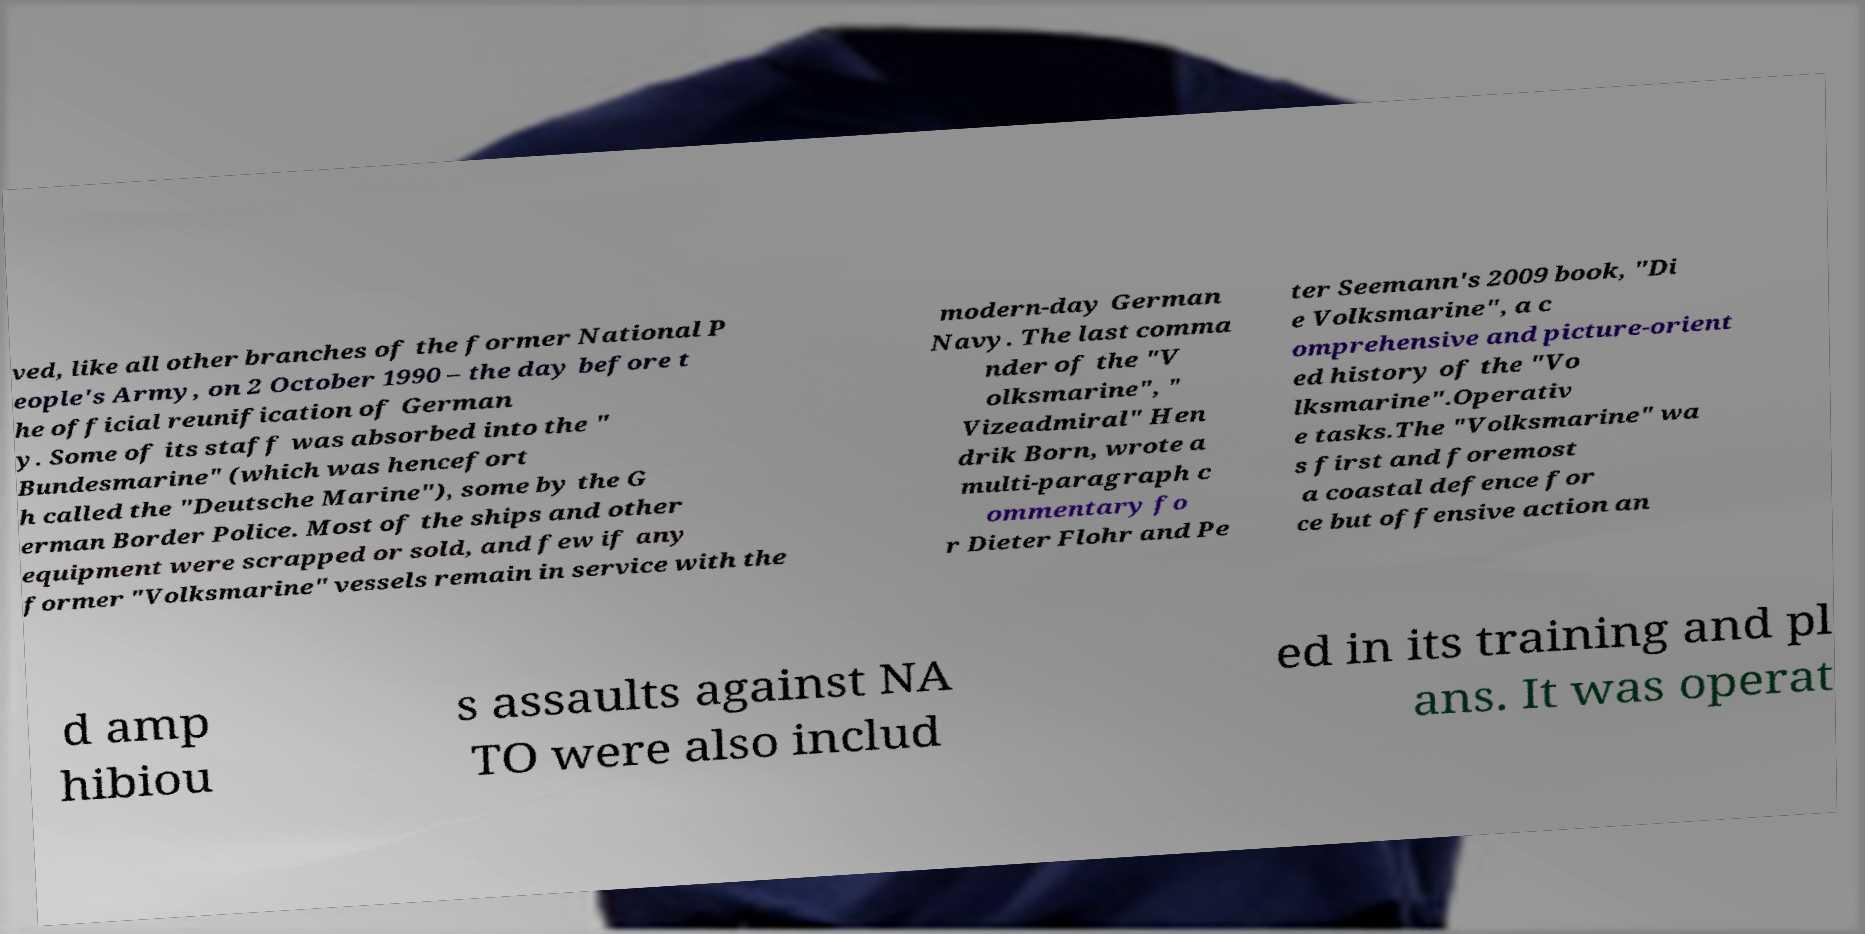Could you assist in decoding the text presented in this image and type it out clearly? ved, like all other branches of the former National P eople's Army, on 2 October 1990 – the day before t he official reunification of German y. Some of its staff was absorbed into the " Bundesmarine" (which was hencefort h called the "Deutsche Marine"), some by the G erman Border Police. Most of the ships and other equipment were scrapped or sold, and few if any former "Volksmarine" vessels remain in service with the modern-day German Navy. The last comma nder of the "V olksmarine", " Vizeadmiral" Hen drik Born, wrote a multi-paragraph c ommentary fo r Dieter Flohr and Pe ter Seemann's 2009 book, "Di e Volksmarine", a c omprehensive and picture-orient ed history of the "Vo lksmarine".Operativ e tasks.The "Volksmarine" wa s first and foremost a coastal defence for ce but offensive action an d amp hibiou s assaults against NA TO were also includ ed in its training and pl ans. It was operat 